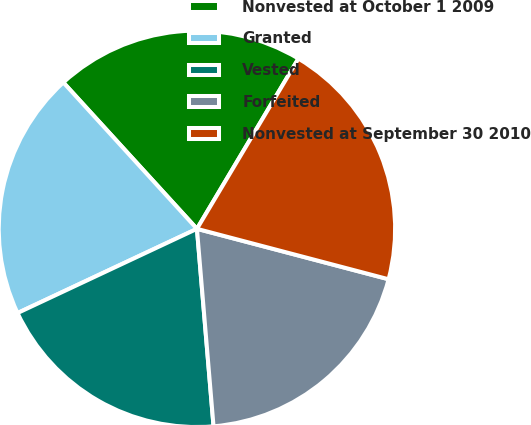<chart> <loc_0><loc_0><loc_500><loc_500><pie_chart><fcel>Nonvested at October 1 2009<fcel>Granted<fcel>Vested<fcel>Forfeited<fcel>Nonvested at September 30 2010<nl><fcel>20.33%<fcel>20.21%<fcel>19.35%<fcel>19.57%<fcel>20.54%<nl></chart> 